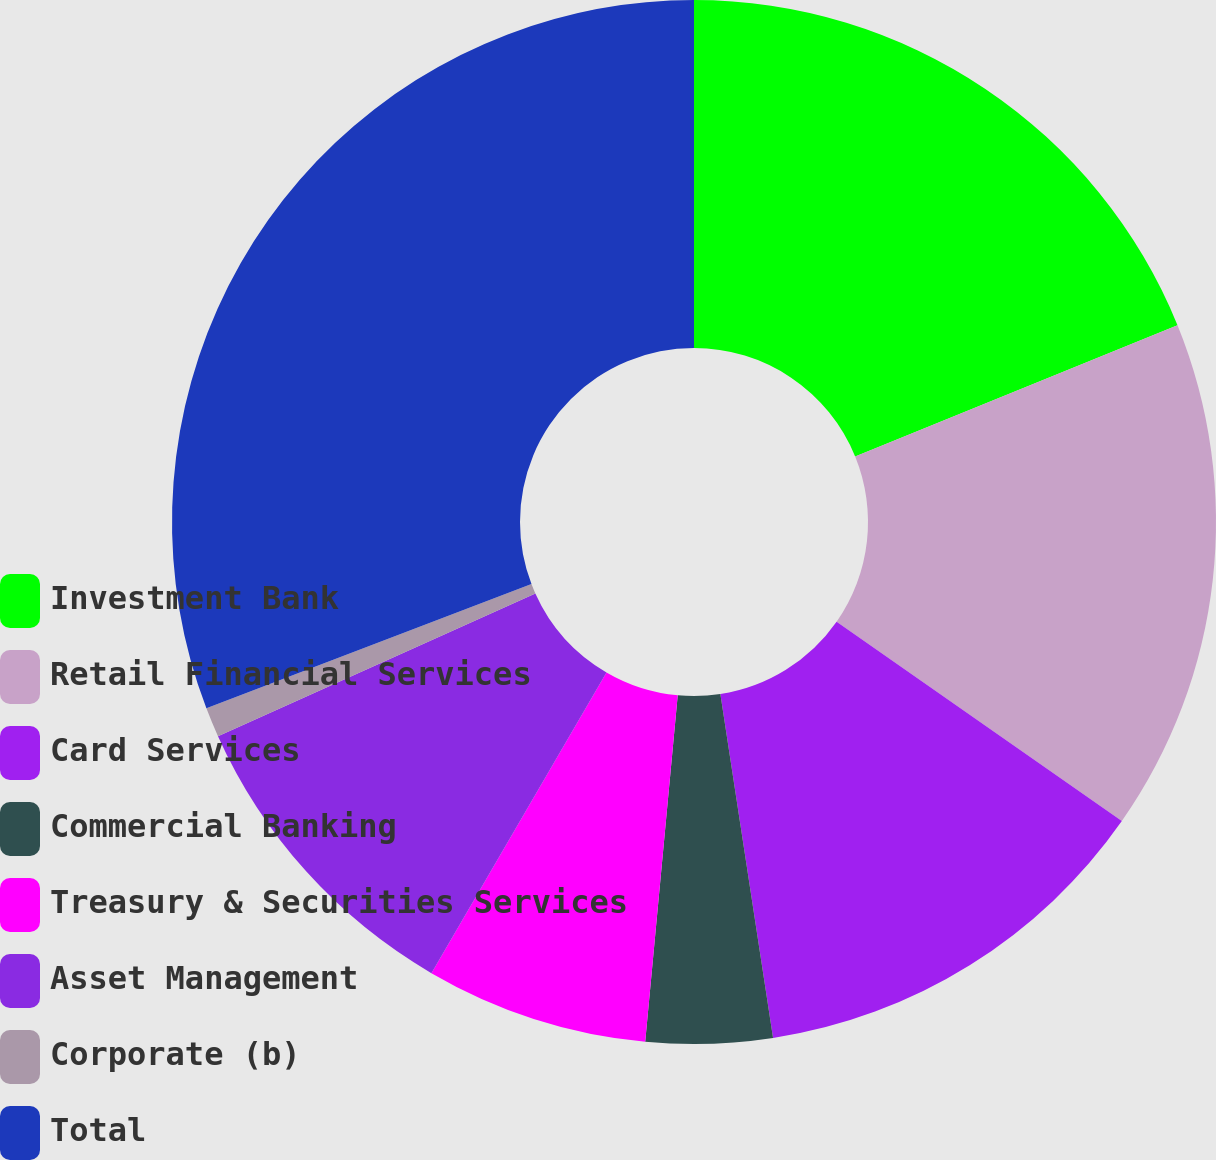Convert chart to OTSL. <chart><loc_0><loc_0><loc_500><loc_500><pie_chart><fcel>Investment Bank<fcel>Retail Financial Services<fcel>Card Services<fcel>Commercial Banking<fcel>Treasury & Securities Services<fcel>Asset Management<fcel>Corporate (b)<fcel>Total<nl><fcel>18.85%<fcel>15.86%<fcel>12.87%<fcel>3.91%<fcel>6.9%<fcel>9.88%<fcel>0.92%<fcel>30.81%<nl></chart> 